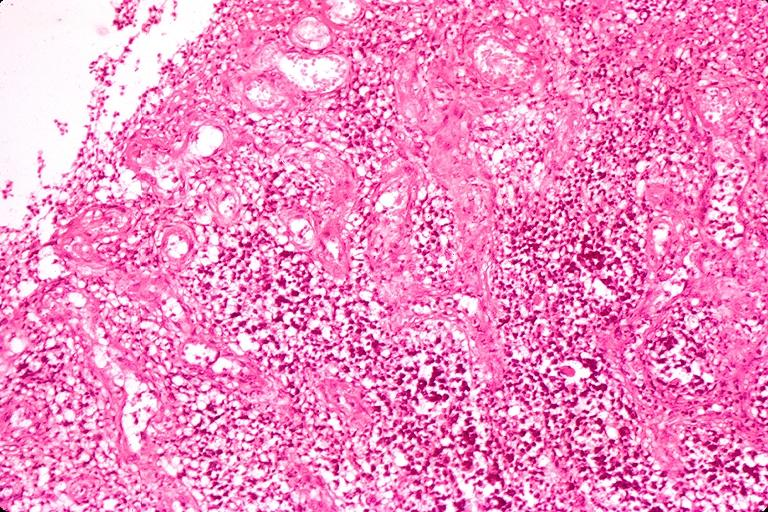does astrocytoma show chronic hyperplasitic pulpitis?
Answer the question using a single word or phrase. No 